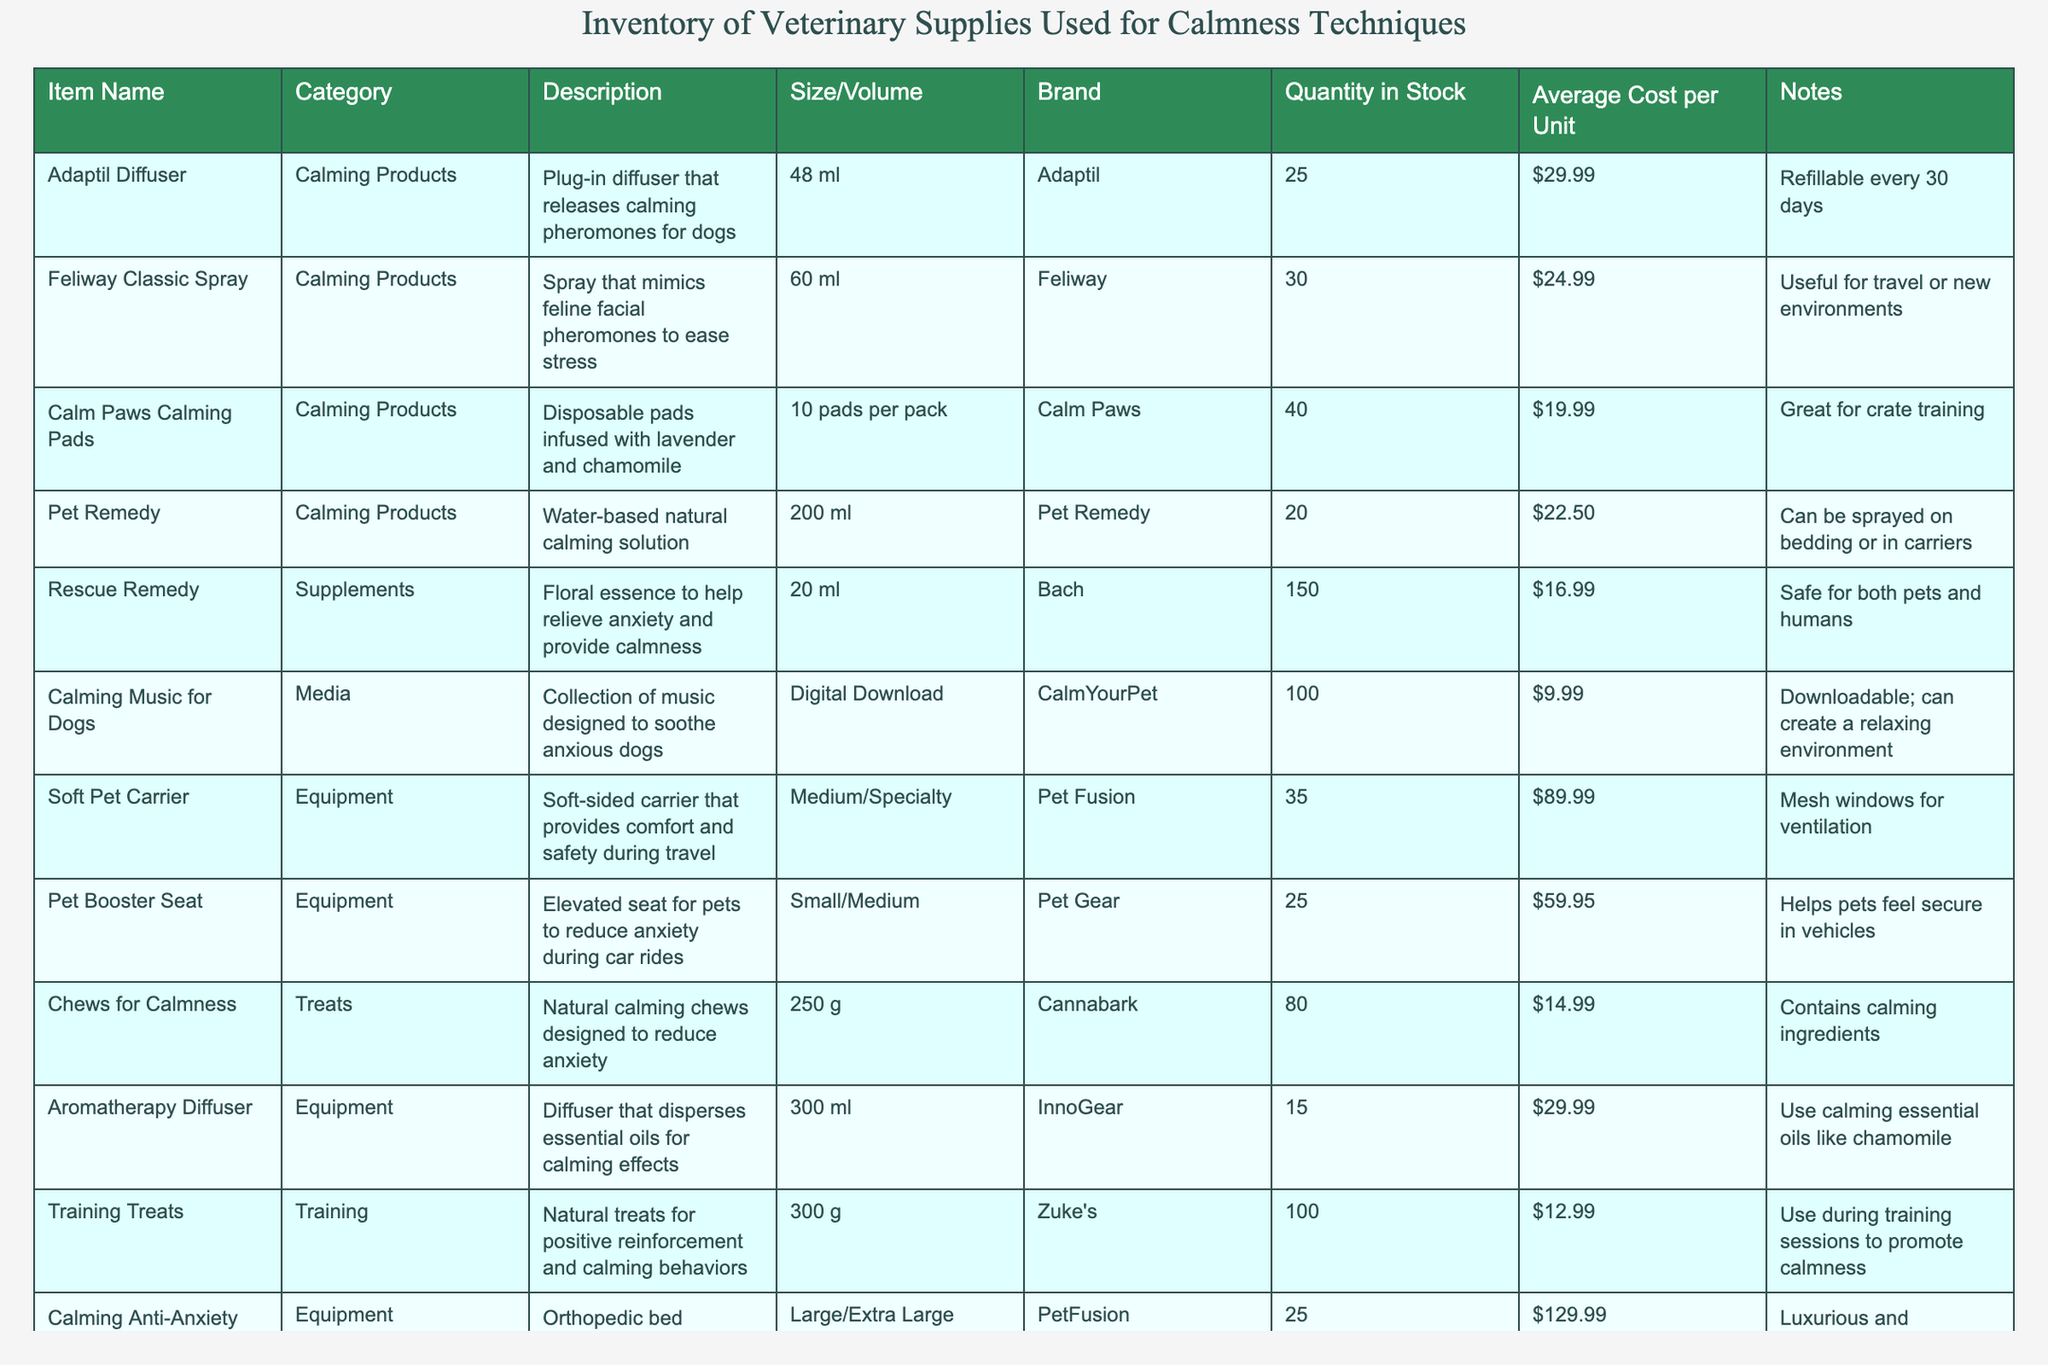What is the total quantity of Feliway Classic Spray in stock? According to the table, the quantity in stock for Feliway Classic Spray is listed as 30.
Answer: 30 How many different calming products are available? By looking at the "Category" column, there are 5 different entries under "Calming Products".
Answer: 5 Which calming product has the highest average cost per unit? Reviewing the "Average Cost per Unit" column, the Cuddle Clone has an average cost of $249.99, the highest among all products.
Answer: Cuddle Clone Is the Rescue Remedy safe for both pets and humans? The notes for Rescue Remedy explicitly state that it is safe for both pets and humans.
Answer: Yes What is the average cost of all calming treats listed? The average cost can be calculated by summing the costs of calming treats: $14.99 (Chews for Calmness) and then dividing by 1 since it’s the only entry under treats: $14.99/1 = $14.99.
Answer: $14.99 How many products have a quantity in stock of 25 or less? Checking the "Quantity in Stock" column, there are three products (Soft Pet Carrier, Cuddle Clone, and Calming Anti-Anxiety Bed) with a quantity of 25 or less.
Answer: 3 Which equipment item is designed for crate training? Looking at the table, Calm Paws Calming Pads are specifically noted as "Great for crate training."
Answer: Calm Paws Calming Pads What is the combined quantity of Pet Remedy and Aromatherapy Diffuser in stock? Summing the quantities of Pet Remedy (20) and Aromatherapy Diffuser (15) gives a total of 20 + 15 = 35.
Answer: 35 What is the average size of the calming equipment items listed? The sizes provided for the equipment items are Medium/Specialty (Soft Pet Carrier), Small/Medium (Pet Booster Seat), Large/Extra Large (Calming Anti-Anxiety Bed), and 300 ml (Aromatherapy Diffuser). Since these sizes aren't numerical values, we cannot compute an average size meaningfully here.
Answer: Not applicable True or False: The Calming Music for Dogs is available as a physical product. The table states that Calming Music for Dogs is available only as a "Digital Download", indicating it is not a physical product.
Answer: False 